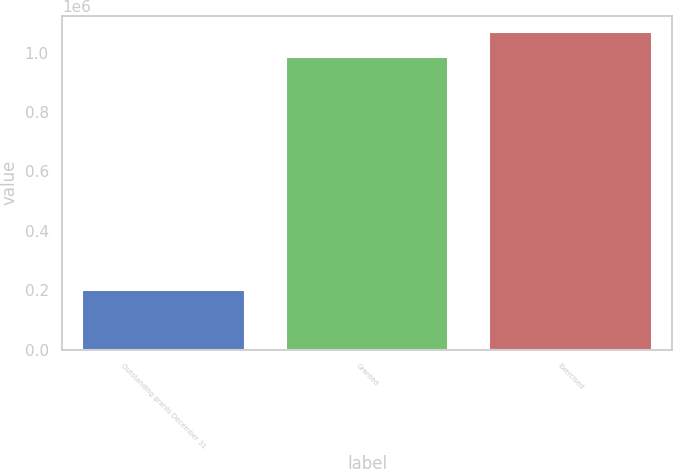Convert chart to OTSL. <chart><loc_0><loc_0><loc_500><loc_500><bar_chart><fcel>Outstanding grants December 31<fcel>Granted<fcel>Exercised<nl><fcel>202179<fcel>984536<fcel>1.07089e+06<nl></chart> 